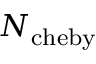<formula> <loc_0><loc_0><loc_500><loc_500>N _ { c h e b y }</formula> 